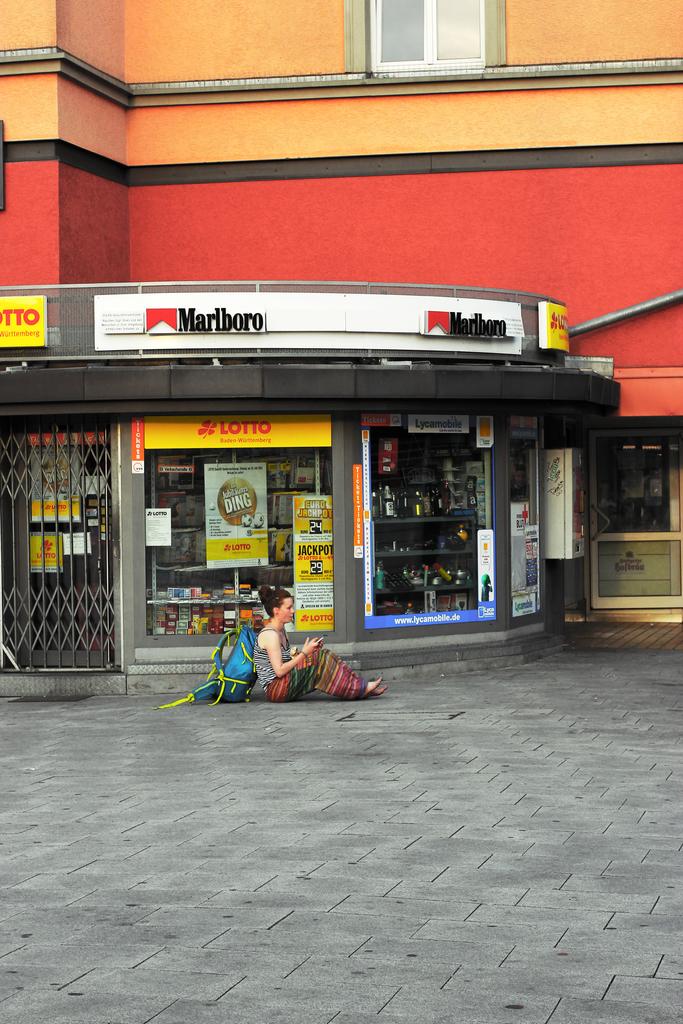What brand of cigaretes are sold?
Provide a short and direct response. Marlboro. 